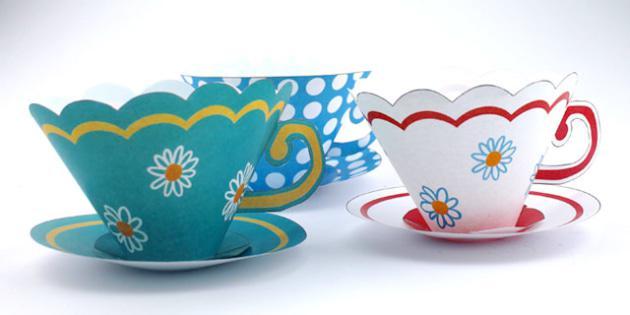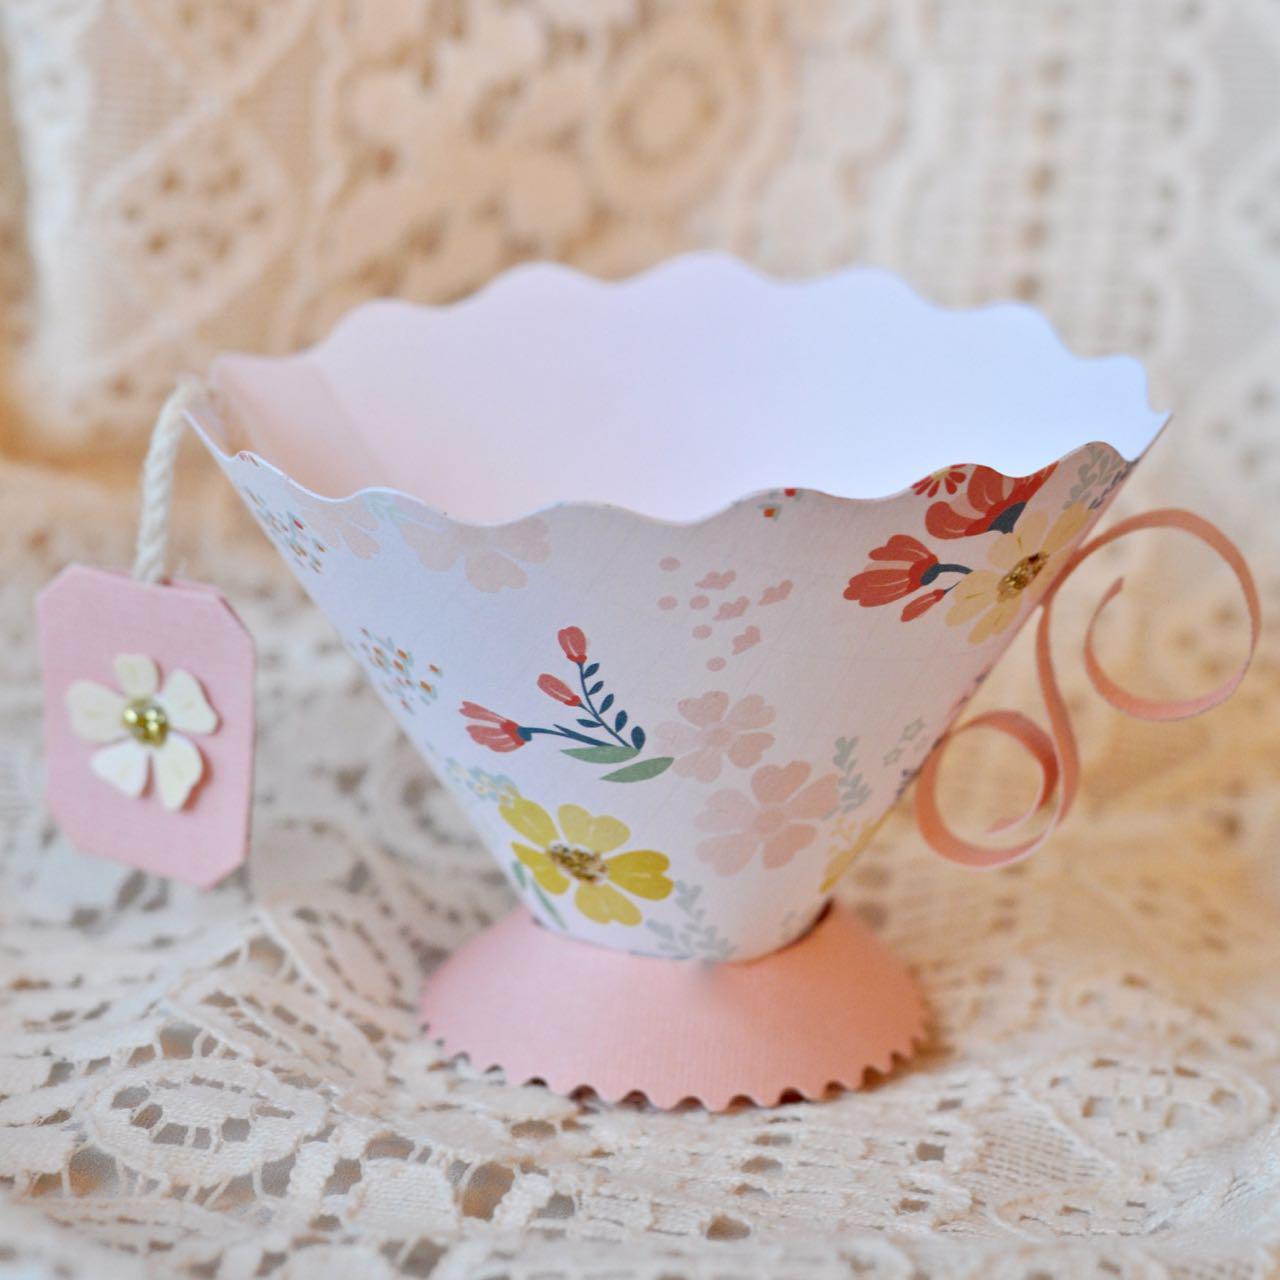The first image is the image on the left, the second image is the image on the right. Assess this claim about the two images: "There are multiple paper cups on the left, but only one on the right.". Correct or not? Answer yes or no. Yes. The first image is the image on the left, the second image is the image on the right. For the images shown, is this caption "There is at least one tower of four paper plates." true? Answer yes or no. No. 